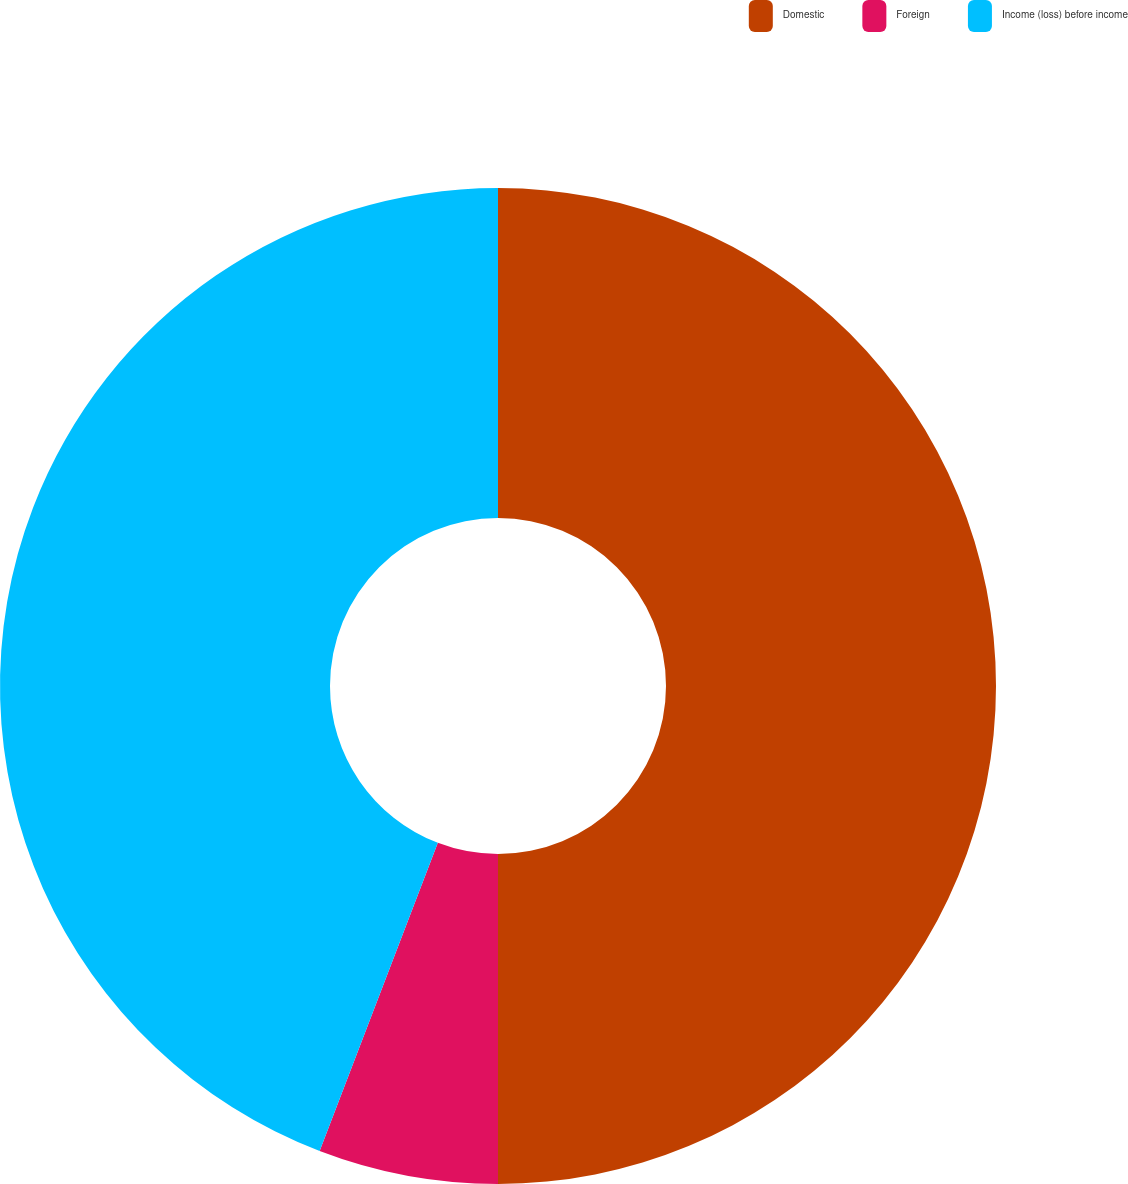Convert chart to OTSL. <chart><loc_0><loc_0><loc_500><loc_500><pie_chart><fcel>Domestic<fcel>Foreign<fcel>Income (loss) before income<nl><fcel>50.0%<fcel>5.83%<fcel>44.17%<nl></chart> 